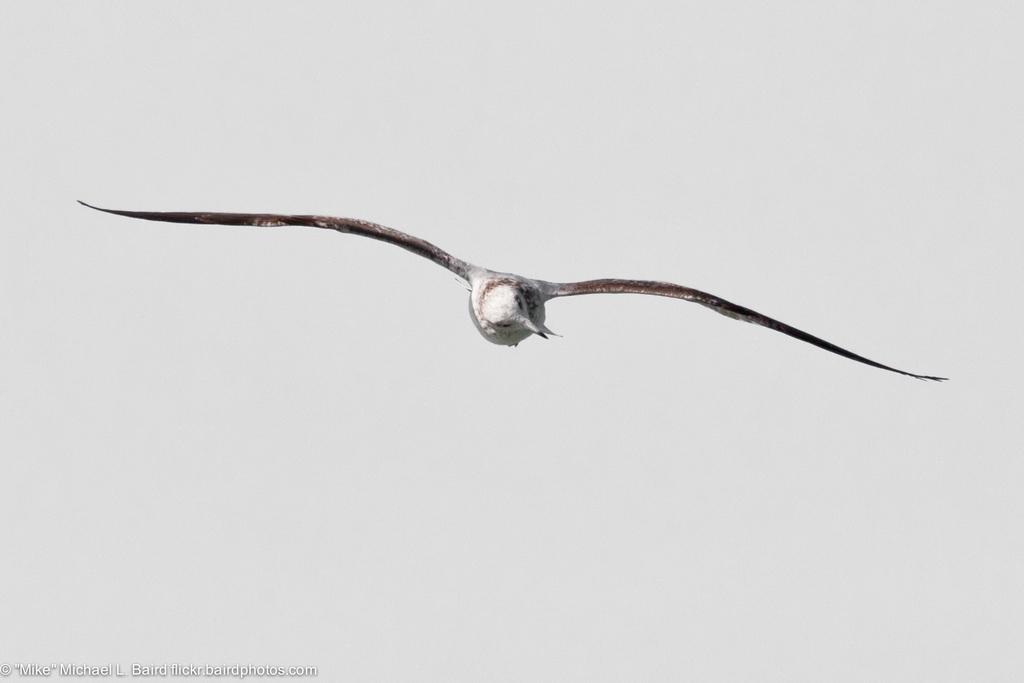How would you summarize this image in a sentence or two? In this image I can see a bird flying in air and the bird is in white and brown color. Background the sky is in white color. 